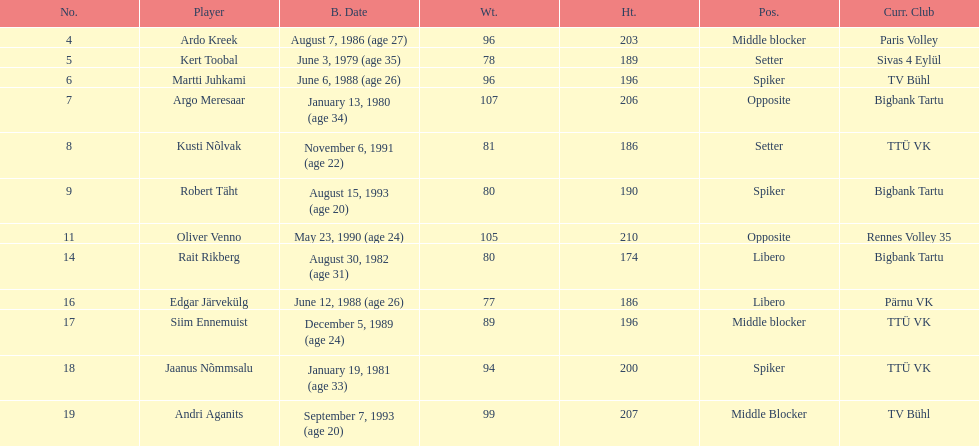Who is at least 25 years or older? Ardo Kreek, Kert Toobal, Martti Juhkami, Argo Meresaar, Rait Rikberg, Edgar Järvekülg, Jaanus Nõmmsalu. I'm looking to parse the entire table for insights. Could you assist me with that? {'header': ['No.', 'Player', 'B. Date', 'Wt.', 'Ht.', 'Pos.', 'Curr. Club'], 'rows': [['4', 'Ardo Kreek', 'August 7, 1986 (age\xa027)', '96', '203', 'Middle blocker', 'Paris Volley'], ['5', 'Kert Toobal', 'June 3, 1979 (age\xa035)', '78', '189', 'Setter', 'Sivas 4 Eylül'], ['6', 'Martti Juhkami', 'June 6, 1988 (age\xa026)', '96', '196', 'Spiker', 'TV Bühl'], ['7', 'Argo Meresaar', 'January 13, 1980 (age\xa034)', '107', '206', 'Opposite', 'Bigbank Tartu'], ['8', 'Kusti Nõlvak', 'November 6, 1991 (age\xa022)', '81', '186', 'Setter', 'TTÜ VK'], ['9', 'Robert Täht', 'August 15, 1993 (age\xa020)', '80', '190', 'Spiker', 'Bigbank Tartu'], ['11', 'Oliver Venno', 'May 23, 1990 (age\xa024)', '105', '210', 'Opposite', 'Rennes Volley 35'], ['14', 'Rait Rikberg', 'August 30, 1982 (age\xa031)', '80', '174', 'Libero', 'Bigbank Tartu'], ['16', 'Edgar Järvekülg', 'June 12, 1988 (age\xa026)', '77', '186', 'Libero', 'Pärnu VK'], ['17', 'Siim Ennemuist', 'December 5, 1989 (age\xa024)', '89', '196', 'Middle blocker', 'TTÜ VK'], ['18', 'Jaanus Nõmmsalu', 'January 19, 1981 (age\xa033)', '94', '200', 'Spiker', 'TTÜ VK'], ['19', 'Andri Aganits', 'September 7, 1993 (age\xa020)', '99', '207', 'Middle Blocker', 'TV Bühl']]} 